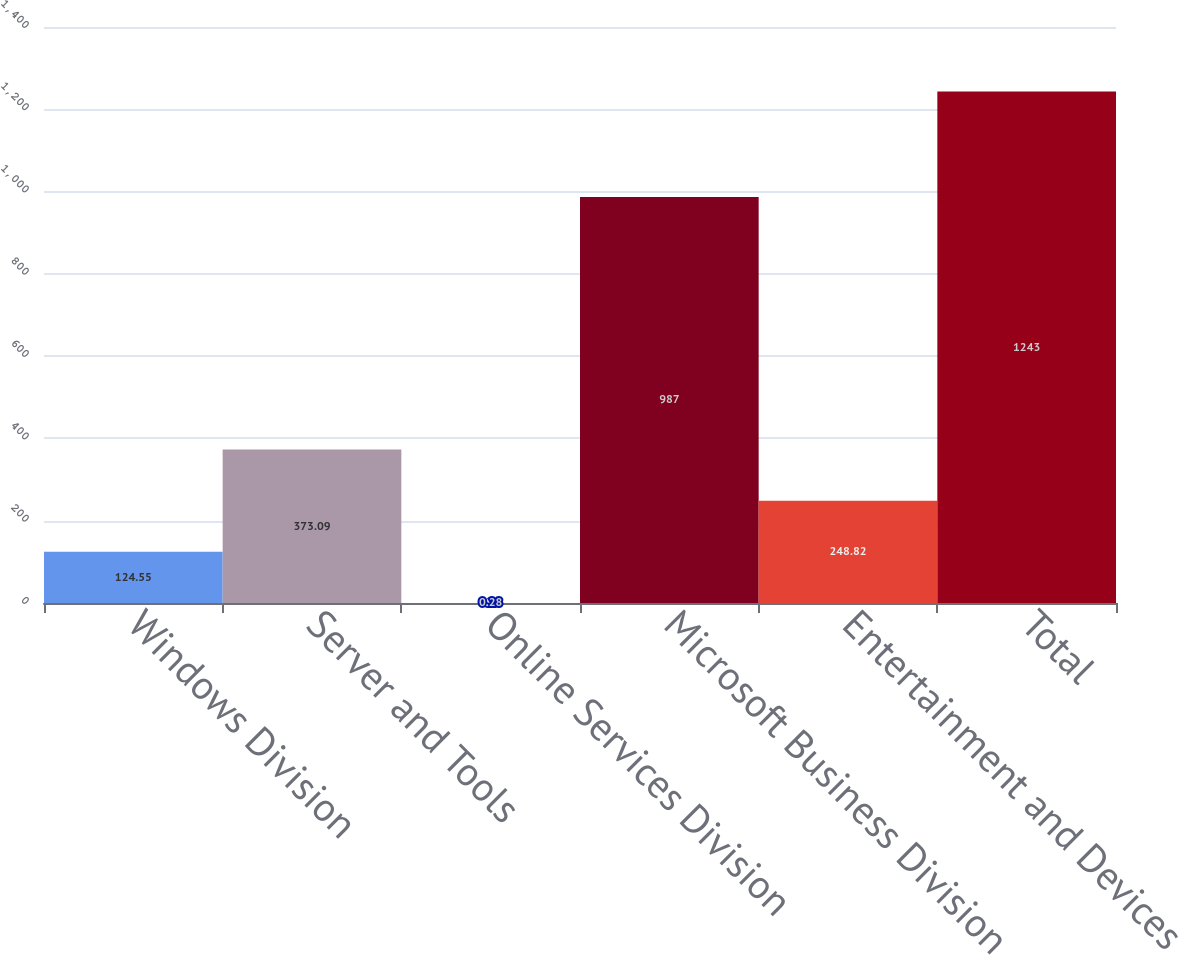Convert chart to OTSL. <chart><loc_0><loc_0><loc_500><loc_500><bar_chart><fcel>Windows Division<fcel>Server and Tools<fcel>Online Services Division<fcel>Microsoft Business Division<fcel>Entertainment and Devices<fcel>Total<nl><fcel>124.55<fcel>373.09<fcel>0.28<fcel>987<fcel>248.82<fcel>1243<nl></chart> 